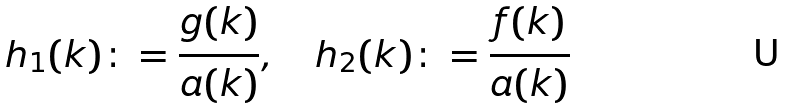<formula> <loc_0><loc_0><loc_500><loc_500>h _ { 1 } ( k ) \colon = \frac { g ( k ) } { a ( k ) } , \quad h _ { 2 } ( k ) \colon = \frac { f ( k ) } { a ( k ) }</formula> 